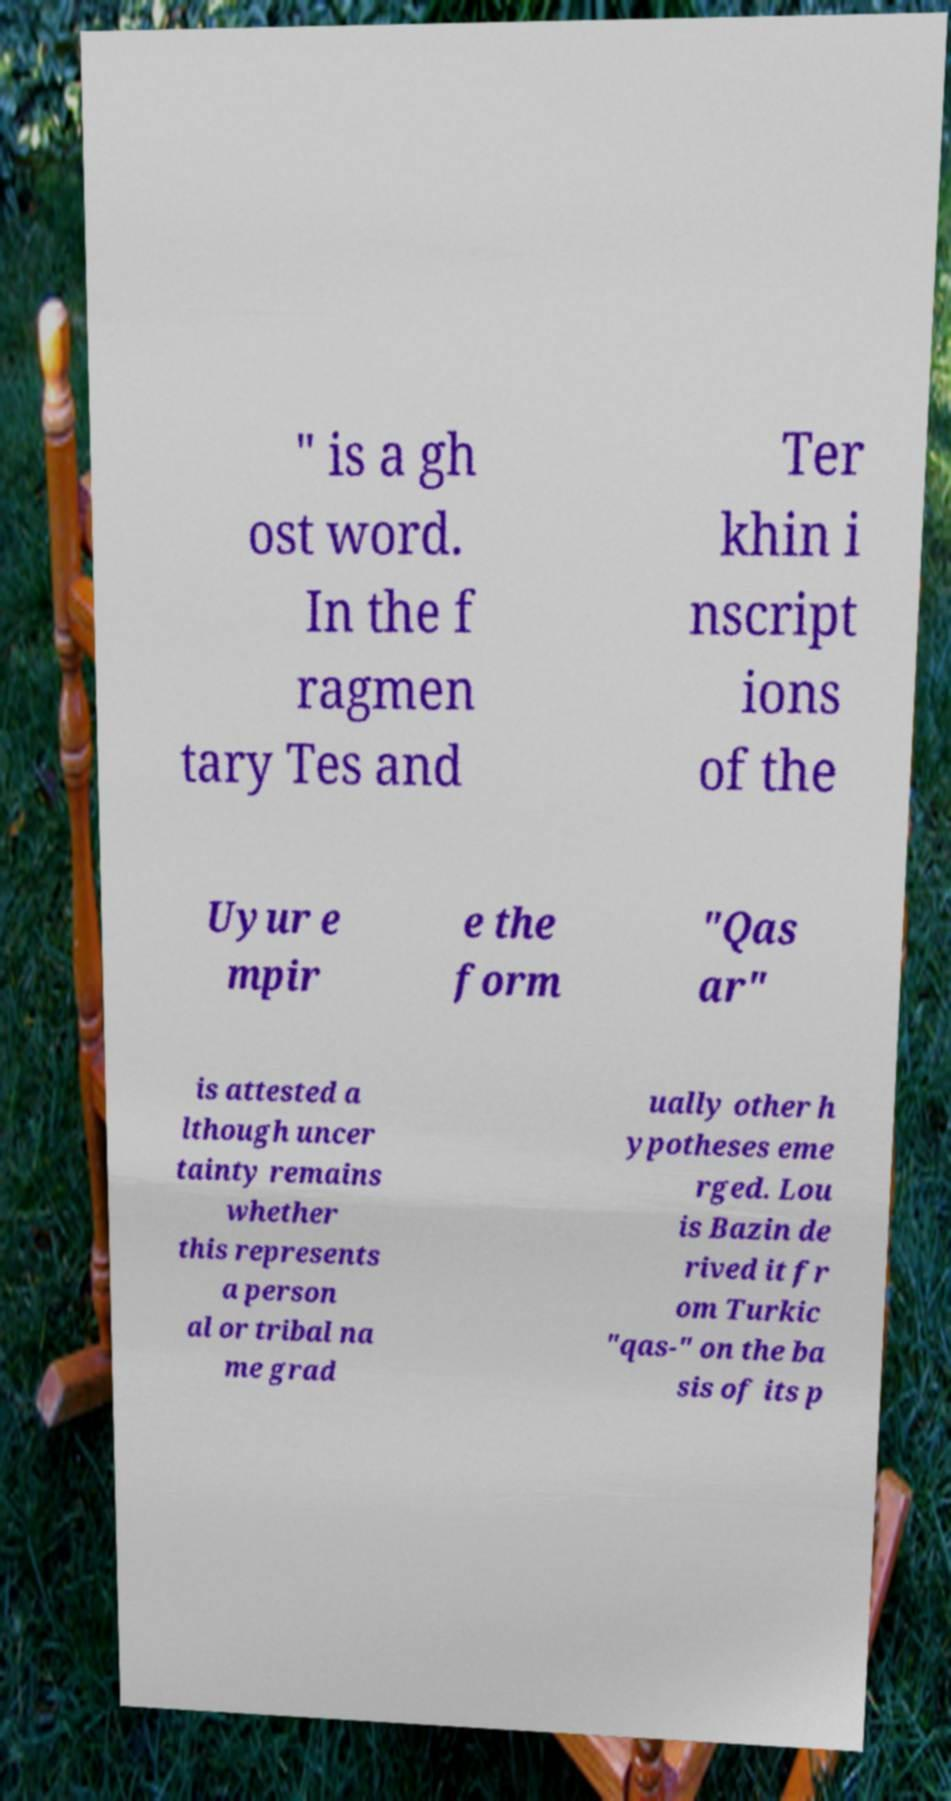I need the written content from this picture converted into text. Can you do that? " is a gh ost word. In the f ragmen tary Tes and Ter khin i nscript ions of the Uyur e mpir e the form "Qas ar" is attested a lthough uncer tainty remains whether this represents a person al or tribal na me grad ually other h ypotheses eme rged. Lou is Bazin de rived it fr om Turkic "qas-" on the ba sis of its p 